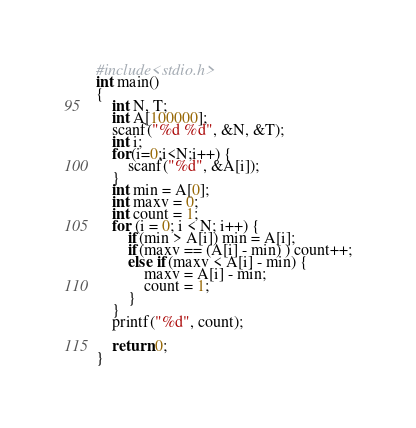Convert code to text. <code><loc_0><loc_0><loc_500><loc_500><_C_>#include<stdio.h>
int main()
{
    int N, T;
	int A[100000];
    scanf("%d %d", &N, &T);
	int i;
	for(i=0;i<N;i++) {
		scanf("%d", &A[i]);
	}
	int min = A[0];
	int maxv = 0;
	int count = 1;
	for (i = 0; i < N; i++) {
		if(min > A[i]) min = A[i];
		if(maxv == (A[i] - min) ) count++;
		else if(maxv < A[i] - min) {
			maxv = A[i] - min;
			count = 1;
		}
	}
	printf("%d", count);
	
	return 0;
}</code> 